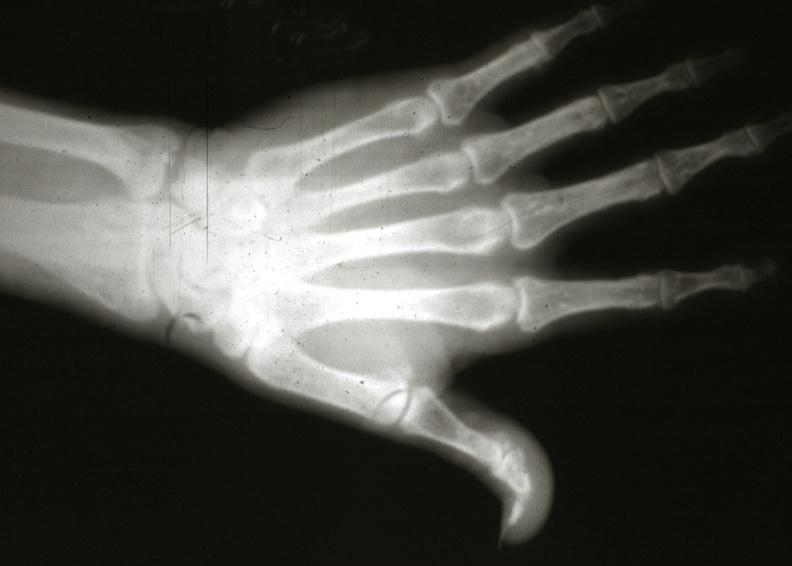what is present?
Answer the question using a single word or phrase. Joints 